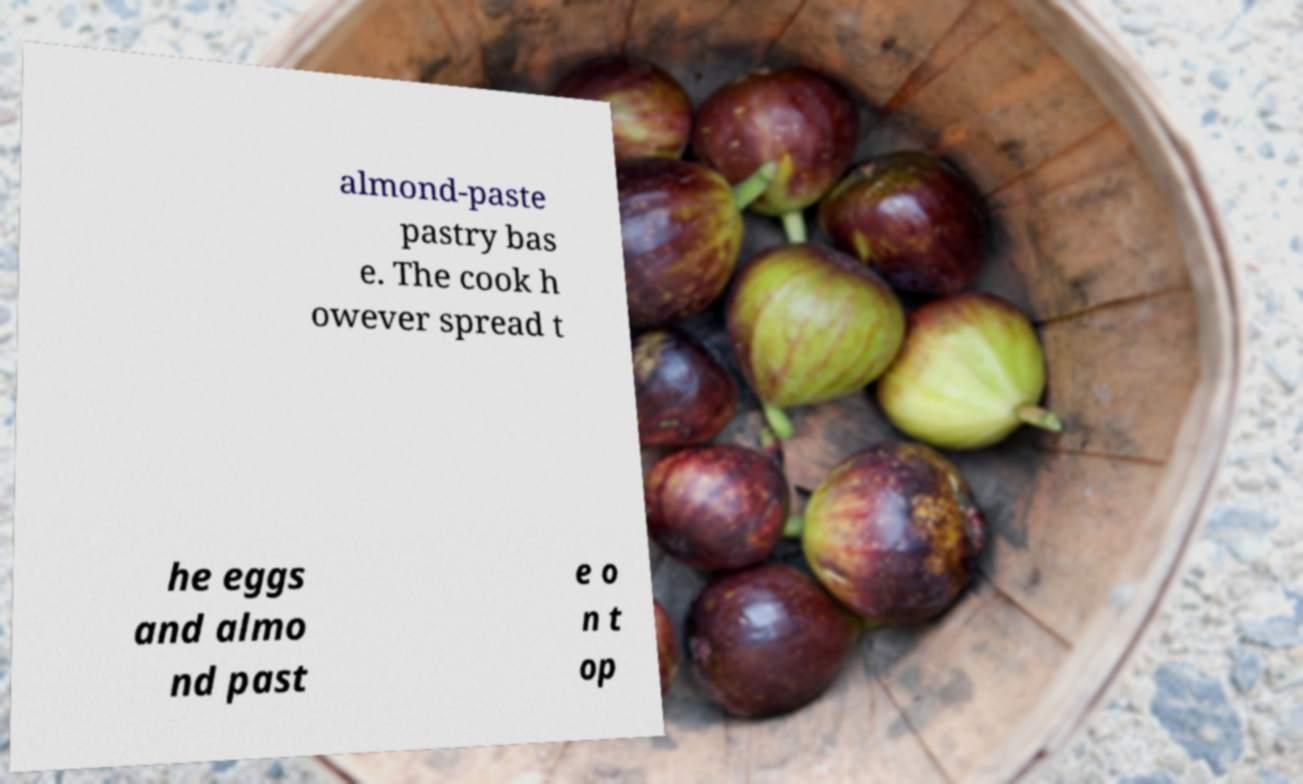I need the written content from this picture converted into text. Can you do that? almond-paste pastry bas e. The cook h owever spread t he eggs and almo nd past e o n t op 